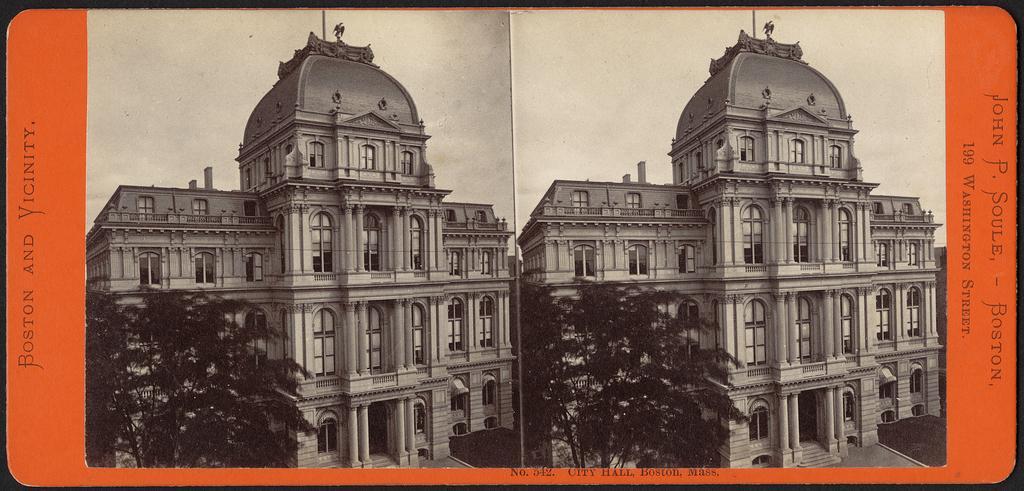Could you give a brief overview of what you see in this image? Here in this picture we can see a poster, in which we can see a couple of old buildings with trees present and we can see the sky is cloudy. 